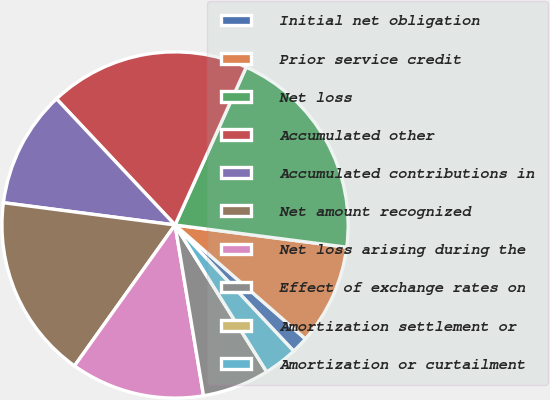Convert chart to OTSL. <chart><loc_0><loc_0><loc_500><loc_500><pie_chart><fcel>Initial net obligation<fcel>Prior service credit<fcel>Net loss<fcel>Accumulated other<fcel>Accumulated contributions in<fcel>Net amount recognized<fcel>Net loss arising during the<fcel>Effect of exchange rates on<fcel>Amortization settlement or<fcel>Amortization or curtailment<nl><fcel>1.56%<fcel>9.38%<fcel>20.31%<fcel>18.75%<fcel>10.94%<fcel>17.19%<fcel>12.5%<fcel>6.25%<fcel>0.0%<fcel>3.13%<nl></chart> 